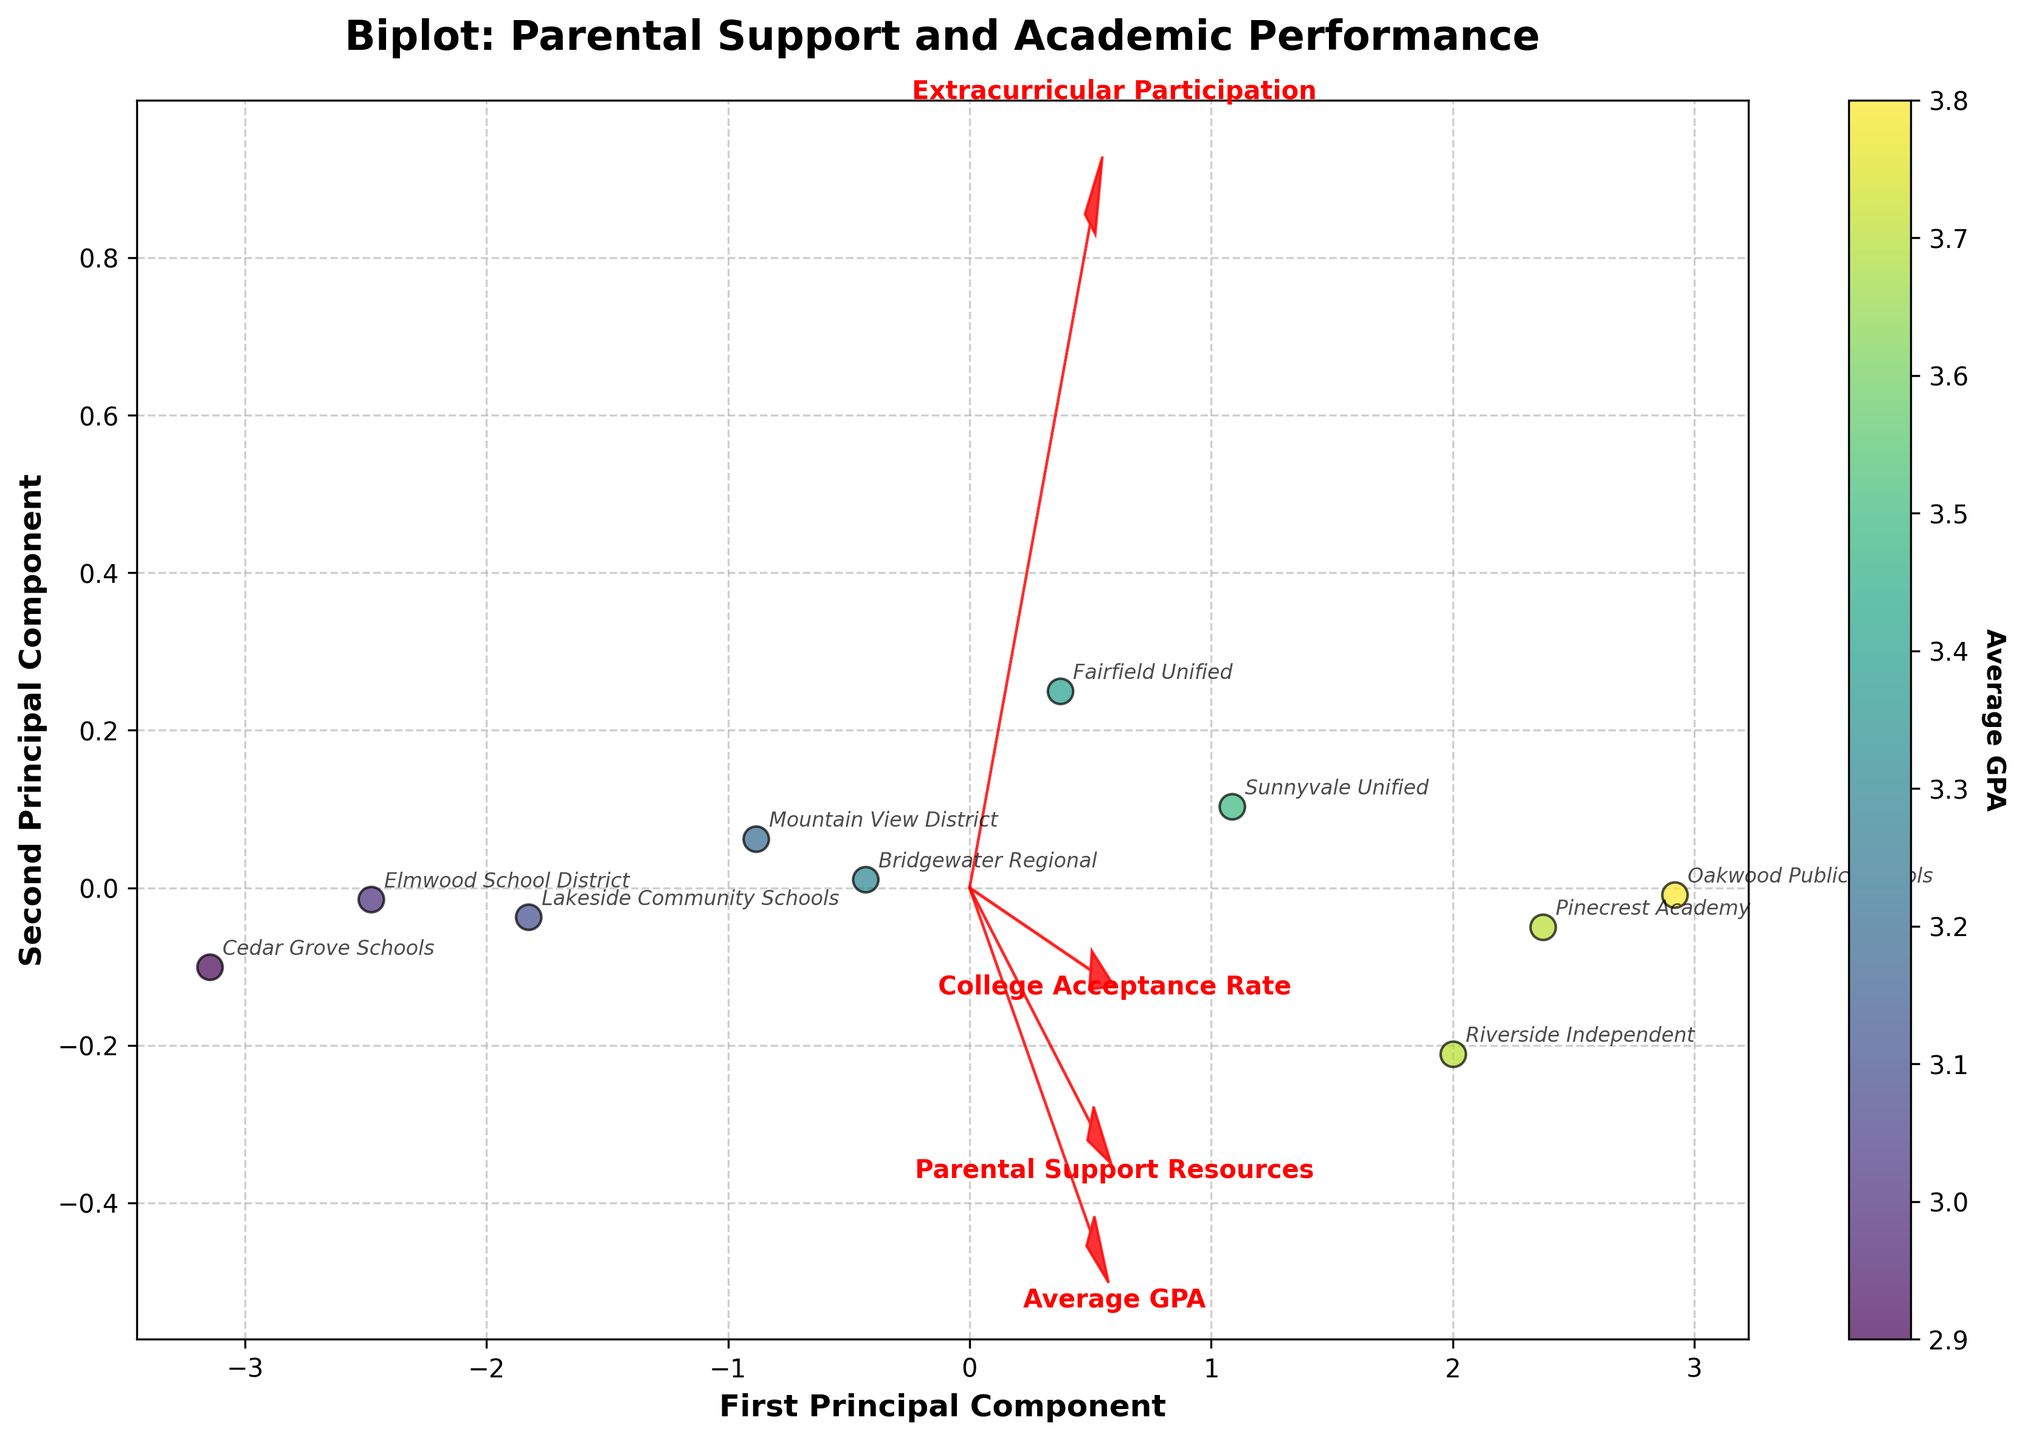What is the title of the biplot? The title of the plot is usually found at the top center of the figure. It provides an overview of what the plot is about.
Answer: Biplot: Parental Support and Academic Performance How many school districts are represented in the biplot? The number of school districts can be determined by counting the unique data points annotated with their respective names in the biplot.
Answer: 10 Which feature has the longest vector in the biplot? The length of a vector in a biplot represents the strength of that feature's influence. By visually comparing the vectors, we can determine which one is the longest.
Answer: Parental Support Resources Which school district appears to have the highest Average GPA based on the color coding? The color coding of the data points is based on the 'Average GPA'. By identifying the data point with the most intense color, we can determine the school district with the highest GPA.
Answer: Oakwood Public Schools Is there a positive correlation between 'Parental Support Resources' and 'Average GPA'? A positive correlation would typically manifest as both vectors pointing in the same or similar direction in the biplot. By observing the angle between the vectors, we can determine if this is the case.
Answer: Yes Which two school districts have the most similar positions in the biplot? Similar positions in the biplot indicate similar values for the features being analyzed. By examining the proximity of the annotated data points, the two closest can be identified.
Answer: Sunnyvale Unified and Fairfield Unified Compare the 'Extracurricular Participation' of Mountain View District and Riverside Independent. To compare, observe the positions of both school districts in relation to the 'Extracurricular Participation' vector direction and magnitude.
Answer: Riverside Independent has higher participation What is the relationship between 'College Acceptance Rate' and 'Average GPA' as shown in the biplot? Observing the angles between the vectors can reveal correlations. If the 'College Acceptance Rate' and 'Average GPA' vectors point in the same direction, they are positively correlated.
Answer: Positive Does Cedar Grove Schools have higher or lower 'Parental Support Resources' compared to Pinecrest Academy? By checking the positions of Cedar Grove Schools and Pinecrest Academy in relation to the 'Parental Support Resources' vector, we can determine which has a higher value.
Answer: Lower Which feature has the smallest influence on the second principal component? The influence on the second principal component is represented by the projection of the feature vector on the y-axis. The smallest projection length indicates the smallest influence.
Answer: College Acceptance Rate 